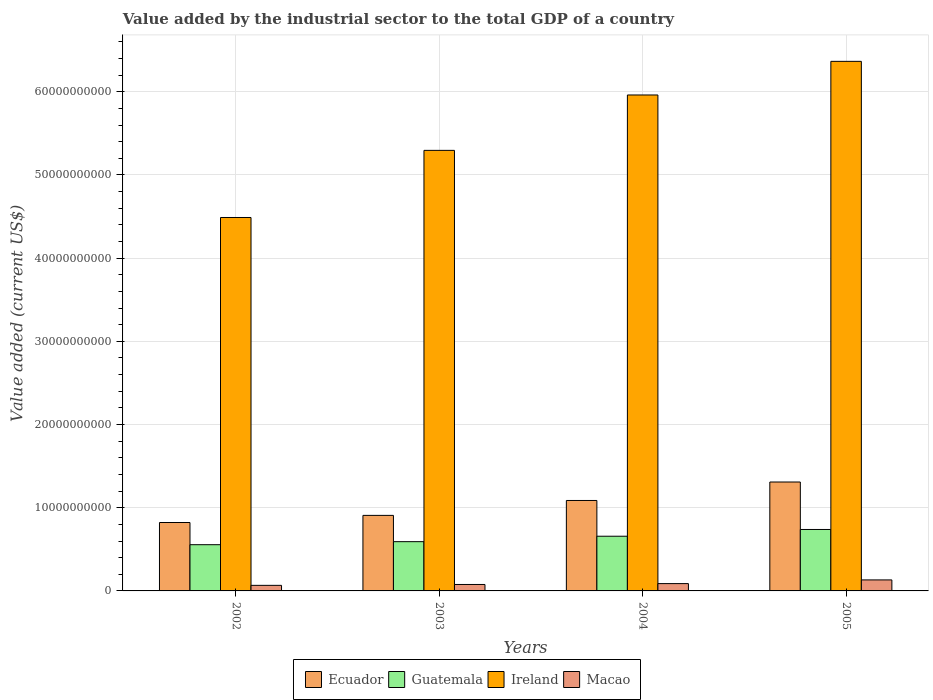Are the number of bars on each tick of the X-axis equal?
Ensure brevity in your answer.  Yes. How many bars are there on the 3rd tick from the left?
Make the answer very short. 4. In how many cases, is the number of bars for a given year not equal to the number of legend labels?
Give a very brief answer. 0. What is the value added by the industrial sector to the total GDP in Ecuador in 2004?
Provide a short and direct response. 1.09e+1. Across all years, what is the maximum value added by the industrial sector to the total GDP in Guatemala?
Your response must be concise. 7.39e+09. Across all years, what is the minimum value added by the industrial sector to the total GDP in Macao?
Provide a short and direct response. 6.69e+08. In which year was the value added by the industrial sector to the total GDP in Guatemala minimum?
Provide a short and direct response. 2002. What is the total value added by the industrial sector to the total GDP in Macao in the graph?
Provide a succinct answer. 3.65e+09. What is the difference between the value added by the industrial sector to the total GDP in Macao in 2004 and that in 2005?
Your answer should be compact. -4.43e+08. What is the difference between the value added by the industrial sector to the total GDP in Ireland in 2003 and the value added by the industrial sector to the total GDP in Guatemala in 2004?
Your answer should be very brief. 4.64e+1. What is the average value added by the industrial sector to the total GDP in Macao per year?
Offer a very short reply. 9.12e+08. In the year 2004, what is the difference between the value added by the industrial sector to the total GDP in Ecuador and value added by the industrial sector to the total GDP in Macao?
Offer a very short reply. 9.99e+09. In how many years, is the value added by the industrial sector to the total GDP in Macao greater than 50000000000 US$?
Provide a succinct answer. 0. What is the ratio of the value added by the industrial sector to the total GDP in Ireland in 2004 to that in 2005?
Ensure brevity in your answer.  0.94. Is the value added by the industrial sector to the total GDP in Macao in 2003 less than that in 2004?
Your answer should be very brief. Yes. What is the difference between the highest and the second highest value added by the industrial sector to the total GDP in Ecuador?
Your response must be concise. 2.22e+09. What is the difference between the highest and the lowest value added by the industrial sector to the total GDP in Macao?
Provide a succinct answer. 6.54e+08. What does the 4th bar from the left in 2005 represents?
Ensure brevity in your answer.  Macao. What does the 4th bar from the right in 2002 represents?
Your response must be concise. Ecuador. Is it the case that in every year, the sum of the value added by the industrial sector to the total GDP in Macao and value added by the industrial sector to the total GDP in Ireland is greater than the value added by the industrial sector to the total GDP in Ecuador?
Ensure brevity in your answer.  Yes. Are the values on the major ticks of Y-axis written in scientific E-notation?
Offer a terse response. No. Does the graph contain grids?
Ensure brevity in your answer.  Yes. Where does the legend appear in the graph?
Make the answer very short. Bottom center. What is the title of the graph?
Provide a short and direct response. Value added by the industrial sector to the total GDP of a country. Does "West Bank and Gaza" appear as one of the legend labels in the graph?
Provide a succinct answer. No. What is the label or title of the Y-axis?
Provide a succinct answer. Value added (current US$). What is the Value added (current US$) in Ecuador in 2002?
Your response must be concise. 8.22e+09. What is the Value added (current US$) in Guatemala in 2002?
Your answer should be compact. 5.56e+09. What is the Value added (current US$) of Ireland in 2002?
Your answer should be compact. 4.49e+1. What is the Value added (current US$) in Macao in 2002?
Make the answer very short. 6.69e+08. What is the Value added (current US$) of Ecuador in 2003?
Your answer should be very brief. 9.08e+09. What is the Value added (current US$) of Guatemala in 2003?
Ensure brevity in your answer.  5.92e+09. What is the Value added (current US$) in Ireland in 2003?
Ensure brevity in your answer.  5.30e+1. What is the Value added (current US$) of Macao in 2003?
Your answer should be compact. 7.75e+08. What is the Value added (current US$) in Ecuador in 2004?
Give a very brief answer. 1.09e+1. What is the Value added (current US$) in Guatemala in 2004?
Ensure brevity in your answer.  6.57e+09. What is the Value added (current US$) in Ireland in 2004?
Keep it short and to the point. 5.96e+1. What is the Value added (current US$) of Macao in 2004?
Your answer should be very brief. 8.80e+08. What is the Value added (current US$) in Ecuador in 2005?
Give a very brief answer. 1.31e+1. What is the Value added (current US$) of Guatemala in 2005?
Provide a succinct answer. 7.39e+09. What is the Value added (current US$) of Ireland in 2005?
Your answer should be very brief. 6.37e+1. What is the Value added (current US$) of Macao in 2005?
Your response must be concise. 1.32e+09. Across all years, what is the maximum Value added (current US$) in Ecuador?
Your answer should be very brief. 1.31e+1. Across all years, what is the maximum Value added (current US$) of Guatemala?
Your answer should be very brief. 7.39e+09. Across all years, what is the maximum Value added (current US$) in Ireland?
Provide a succinct answer. 6.37e+1. Across all years, what is the maximum Value added (current US$) of Macao?
Provide a short and direct response. 1.32e+09. Across all years, what is the minimum Value added (current US$) of Ecuador?
Give a very brief answer. 8.22e+09. Across all years, what is the minimum Value added (current US$) in Guatemala?
Your response must be concise. 5.56e+09. Across all years, what is the minimum Value added (current US$) of Ireland?
Give a very brief answer. 4.49e+1. Across all years, what is the minimum Value added (current US$) of Macao?
Your answer should be very brief. 6.69e+08. What is the total Value added (current US$) in Ecuador in the graph?
Offer a terse response. 4.13e+1. What is the total Value added (current US$) in Guatemala in the graph?
Provide a short and direct response. 2.54e+1. What is the total Value added (current US$) of Ireland in the graph?
Ensure brevity in your answer.  2.21e+11. What is the total Value added (current US$) of Macao in the graph?
Your answer should be compact. 3.65e+09. What is the difference between the Value added (current US$) of Ecuador in 2002 and that in 2003?
Provide a succinct answer. -8.57e+08. What is the difference between the Value added (current US$) of Guatemala in 2002 and that in 2003?
Offer a terse response. -3.64e+08. What is the difference between the Value added (current US$) of Ireland in 2002 and that in 2003?
Give a very brief answer. -8.07e+09. What is the difference between the Value added (current US$) in Macao in 2002 and that in 2003?
Your answer should be very brief. -1.06e+08. What is the difference between the Value added (current US$) of Ecuador in 2002 and that in 2004?
Your answer should be compact. -2.65e+09. What is the difference between the Value added (current US$) of Guatemala in 2002 and that in 2004?
Ensure brevity in your answer.  -1.02e+09. What is the difference between the Value added (current US$) of Ireland in 2002 and that in 2004?
Provide a succinct answer. -1.47e+1. What is the difference between the Value added (current US$) of Macao in 2002 and that in 2004?
Your answer should be compact. -2.12e+08. What is the difference between the Value added (current US$) of Ecuador in 2002 and that in 2005?
Provide a succinct answer. -4.87e+09. What is the difference between the Value added (current US$) of Guatemala in 2002 and that in 2005?
Give a very brief answer. -1.83e+09. What is the difference between the Value added (current US$) of Ireland in 2002 and that in 2005?
Offer a terse response. -1.88e+1. What is the difference between the Value added (current US$) of Macao in 2002 and that in 2005?
Offer a very short reply. -6.54e+08. What is the difference between the Value added (current US$) in Ecuador in 2003 and that in 2004?
Give a very brief answer. -1.79e+09. What is the difference between the Value added (current US$) in Guatemala in 2003 and that in 2004?
Ensure brevity in your answer.  -6.53e+08. What is the difference between the Value added (current US$) of Ireland in 2003 and that in 2004?
Your answer should be compact. -6.66e+09. What is the difference between the Value added (current US$) of Macao in 2003 and that in 2004?
Your response must be concise. -1.05e+08. What is the difference between the Value added (current US$) of Ecuador in 2003 and that in 2005?
Offer a terse response. -4.01e+09. What is the difference between the Value added (current US$) of Guatemala in 2003 and that in 2005?
Offer a very short reply. -1.47e+09. What is the difference between the Value added (current US$) in Ireland in 2003 and that in 2005?
Keep it short and to the point. -1.07e+1. What is the difference between the Value added (current US$) in Macao in 2003 and that in 2005?
Ensure brevity in your answer.  -5.48e+08. What is the difference between the Value added (current US$) in Ecuador in 2004 and that in 2005?
Keep it short and to the point. -2.22e+09. What is the difference between the Value added (current US$) of Guatemala in 2004 and that in 2005?
Provide a short and direct response. -8.13e+08. What is the difference between the Value added (current US$) of Ireland in 2004 and that in 2005?
Give a very brief answer. -4.04e+09. What is the difference between the Value added (current US$) in Macao in 2004 and that in 2005?
Provide a short and direct response. -4.43e+08. What is the difference between the Value added (current US$) in Ecuador in 2002 and the Value added (current US$) in Guatemala in 2003?
Give a very brief answer. 2.30e+09. What is the difference between the Value added (current US$) of Ecuador in 2002 and the Value added (current US$) of Ireland in 2003?
Your answer should be compact. -4.47e+1. What is the difference between the Value added (current US$) in Ecuador in 2002 and the Value added (current US$) in Macao in 2003?
Provide a short and direct response. 7.45e+09. What is the difference between the Value added (current US$) in Guatemala in 2002 and the Value added (current US$) in Ireland in 2003?
Provide a succinct answer. -4.74e+1. What is the difference between the Value added (current US$) in Guatemala in 2002 and the Value added (current US$) in Macao in 2003?
Your answer should be very brief. 4.78e+09. What is the difference between the Value added (current US$) in Ireland in 2002 and the Value added (current US$) in Macao in 2003?
Offer a very short reply. 4.41e+1. What is the difference between the Value added (current US$) in Ecuador in 2002 and the Value added (current US$) in Guatemala in 2004?
Your answer should be very brief. 1.65e+09. What is the difference between the Value added (current US$) of Ecuador in 2002 and the Value added (current US$) of Ireland in 2004?
Make the answer very short. -5.14e+1. What is the difference between the Value added (current US$) in Ecuador in 2002 and the Value added (current US$) in Macao in 2004?
Offer a very short reply. 7.34e+09. What is the difference between the Value added (current US$) in Guatemala in 2002 and the Value added (current US$) in Ireland in 2004?
Offer a very short reply. -5.41e+1. What is the difference between the Value added (current US$) in Guatemala in 2002 and the Value added (current US$) in Macao in 2004?
Ensure brevity in your answer.  4.68e+09. What is the difference between the Value added (current US$) in Ireland in 2002 and the Value added (current US$) in Macao in 2004?
Give a very brief answer. 4.40e+1. What is the difference between the Value added (current US$) of Ecuador in 2002 and the Value added (current US$) of Guatemala in 2005?
Your answer should be compact. 8.37e+08. What is the difference between the Value added (current US$) of Ecuador in 2002 and the Value added (current US$) of Ireland in 2005?
Keep it short and to the point. -5.54e+1. What is the difference between the Value added (current US$) in Ecuador in 2002 and the Value added (current US$) in Macao in 2005?
Offer a very short reply. 6.90e+09. What is the difference between the Value added (current US$) of Guatemala in 2002 and the Value added (current US$) of Ireland in 2005?
Offer a very short reply. -5.81e+1. What is the difference between the Value added (current US$) in Guatemala in 2002 and the Value added (current US$) in Macao in 2005?
Provide a succinct answer. 4.23e+09. What is the difference between the Value added (current US$) of Ireland in 2002 and the Value added (current US$) of Macao in 2005?
Your answer should be very brief. 4.36e+1. What is the difference between the Value added (current US$) of Ecuador in 2003 and the Value added (current US$) of Guatemala in 2004?
Keep it short and to the point. 2.51e+09. What is the difference between the Value added (current US$) of Ecuador in 2003 and the Value added (current US$) of Ireland in 2004?
Ensure brevity in your answer.  -5.05e+1. What is the difference between the Value added (current US$) of Ecuador in 2003 and the Value added (current US$) of Macao in 2004?
Your response must be concise. 8.20e+09. What is the difference between the Value added (current US$) of Guatemala in 2003 and the Value added (current US$) of Ireland in 2004?
Provide a succinct answer. -5.37e+1. What is the difference between the Value added (current US$) of Guatemala in 2003 and the Value added (current US$) of Macao in 2004?
Your answer should be compact. 5.04e+09. What is the difference between the Value added (current US$) of Ireland in 2003 and the Value added (current US$) of Macao in 2004?
Your response must be concise. 5.21e+1. What is the difference between the Value added (current US$) of Ecuador in 2003 and the Value added (current US$) of Guatemala in 2005?
Offer a very short reply. 1.69e+09. What is the difference between the Value added (current US$) in Ecuador in 2003 and the Value added (current US$) in Ireland in 2005?
Ensure brevity in your answer.  -5.46e+1. What is the difference between the Value added (current US$) of Ecuador in 2003 and the Value added (current US$) of Macao in 2005?
Your answer should be very brief. 7.76e+09. What is the difference between the Value added (current US$) of Guatemala in 2003 and the Value added (current US$) of Ireland in 2005?
Keep it short and to the point. -5.77e+1. What is the difference between the Value added (current US$) of Guatemala in 2003 and the Value added (current US$) of Macao in 2005?
Keep it short and to the point. 4.60e+09. What is the difference between the Value added (current US$) of Ireland in 2003 and the Value added (current US$) of Macao in 2005?
Your answer should be compact. 5.16e+1. What is the difference between the Value added (current US$) of Ecuador in 2004 and the Value added (current US$) of Guatemala in 2005?
Give a very brief answer. 3.48e+09. What is the difference between the Value added (current US$) in Ecuador in 2004 and the Value added (current US$) in Ireland in 2005?
Give a very brief answer. -5.28e+1. What is the difference between the Value added (current US$) in Ecuador in 2004 and the Value added (current US$) in Macao in 2005?
Ensure brevity in your answer.  9.55e+09. What is the difference between the Value added (current US$) in Guatemala in 2004 and the Value added (current US$) in Ireland in 2005?
Ensure brevity in your answer.  -5.71e+1. What is the difference between the Value added (current US$) of Guatemala in 2004 and the Value added (current US$) of Macao in 2005?
Your answer should be compact. 5.25e+09. What is the difference between the Value added (current US$) of Ireland in 2004 and the Value added (current US$) of Macao in 2005?
Make the answer very short. 5.83e+1. What is the average Value added (current US$) of Ecuador per year?
Keep it short and to the point. 1.03e+1. What is the average Value added (current US$) in Guatemala per year?
Offer a very short reply. 6.36e+09. What is the average Value added (current US$) of Ireland per year?
Offer a terse response. 5.53e+1. What is the average Value added (current US$) of Macao per year?
Your answer should be very brief. 9.12e+08. In the year 2002, what is the difference between the Value added (current US$) of Ecuador and Value added (current US$) of Guatemala?
Ensure brevity in your answer.  2.67e+09. In the year 2002, what is the difference between the Value added (current US$) in Ecuador and Value added (current US$) in Ireland?
Provide a short and direct response. -3.67e+1. In the year 2002, what is the difference between the Value added (current US$) in Ecuador and Value added (current US$) in Macao?
Offer a terse response. 7.56e+09. In the year 2002, what is the difference between the Value added (current US$) of Guatemala and Value added (current US$) of Ireland?
Your answer should be very brief. -3.93e+1. In the year 2002, what is the difference between the Value added (current US$) in Guatemala and Value added (current US$) in Macao?
Offer a terse response. 4.89e+09. In the year 2002, what is the difference between the Value added (current US$) in Ireland and Value added (current US$) in Macao?
Your answer should be very brief. 4.42e+1. In the year 2003, what is the difference between the Value added (current US$) in Ecuador and Value added (current US$) in Guatemala?
Provide a succinct answer. 3.16e+09. In the year 2003, what is the difference between the Value added (current US$) of Ecuador and Value added (current US$) of Ireland?
Your answer should be very brief. -4.39e+1. In the year 2003, what is the difference between the Value added (current US$) of Ecuador and Value added (current US$) of Macao?
Your answer should be compact. 8.31e+09. In the year 2003, what is the difference between the Value added (current US$) in Guatemala and Value added (current US$) in Ireland?
Give a very brief answer. -4.70e+1. In the year 2003, what is the difference between the Value added (current US$) in Guatemala and Value added (current US$) in Macao?
Provide a succinct answer. 5.15e+09. In the year 2003, what is the difference between the Value added (current US$) of Ireland and Value added (current US$) of Macao?
Your response must be concise. 5.22e+1. In the year 2004, what is the difference between the Value added (current US$) of Ecuador and Value added (current US$) of Guatemala?
Your response must be concise. 4.30e+09. In the year 2004, what is the difference between the Value added (current US$) in Ecuador and Value added (current US$) in Ireland?
Keep it short and to the point. -4.87e+1. In the year 2004, what is the difference between the Value added (current US$) in Ecuador and Value added (current US$) in Macao?
Provide a succinct answer. 9.99e+09. In the year 2004, what is the difference between the Value added (current US$) in Guatemala and Value added (current US$) in Ireland?
Your answer should be compact. -5.30e+1. In the year 2004, what is the difference between the Value added (current US$) of Guatemala and Value added (current US$) of Macao?
Make the answer very short. 5.69e+09. In the year 2004, what is the difference between the Value added (current US$) in Ireland and Value added (current US$) in Macao?
Provide a short and direct response. 5.87e+1. In the year 2005, what is the difference between the Value added (current US$) of Ecuador and Value added (current US$) of Guatemala?
Offer a very short reply. 5.71e+09. In the year 2005, what is the difference between the Value added (current US$) of Ecuador and Value added (current US$) of Ireland?
Offer a very short reply. -5.06e+1. In the year 2005, what is the difference between the Value added (current US$) of Ecuador and Value added (current US$) of Macao?
Your response must be concise. 1.18e+1. In the year 2005, what is the difference between the Value added (current US$) of Guatemala and Value added (current US$) of Ireland?
Provide a succinct answer. -5.63e+1. In the year 2005, what is the difference between the Value added (current US$) in Guatemala and Value added (current US$) in Macao?
Make the answer very short. 6.06e+09. In the year 2005, what is the difference between the Value added (current US$) of Ireland and Value added (current US$) of Macao?
Offer a terse response. 6.23e+1. What is the ratio of the Value added (current US$) of Ecuador in 2002 to that in 2003?
Give a very brief answer. 0.91. What is the ratio of the Value added (current US$) in Guatemala in 2002 to that in 2003?
Offer a very short reply. 0.94. What is the ratio of the Value added (current US$) in Ireland in 2002 to that in 2003?
Your answer should be very brief. 0.85. What is the ratio of the Value added (current US$) of Macao in 2002 to that in 2003?
Offer a very short reply. 0.86. What is the ratio of the Value added (current US$) of Ecuador in 2002 to that in 2004?
Ensure brevity in your answer.  0.76. What is the ratio of the Value added (current US$) in Guatemala in 2002 to that in 2004?
Offer a very short reply. 0.85. What is the ratio of the Value added (current US$) of Ireland in 2002 to that in 2004?
Provide a succinct answer. 0.75. What is the ratio of the Value added (current US$) of Macao in 2002 to that in 2004?
Your response must be concise. 0.76. What is the ratio of the Value added (current US$) in Ecuador in 2002 to that in 2005?
Your answer should be very brief. 0.63. What is the ratio of the Value added (current US$) in Guatemala in 2002 to that in 2005?
Ensure brevity in your answer.  0.75. What is the ratio of the Value added (current US$) of Ireland in 2002 to that in 2005?
Ensure brevity in your answer.  0.71. What is the ratio of the Value added (current US$) of Macao in 2002 to that in 2005?
Your response must be concise. 0.51. What is the ratio of the Value added (current US$) in Ecuador in 2003 to that in 2004?
Your response must be concise. 0.84. What is the ratio of the Value added (current US$) of Guatemala in 2003 to that in 2004?
Keep it short and to the point. 0.9. What is the ratio of the Value added (current US$) in Ireland in 2003 to that in 2004?
Give a very brief answer. 0.89. What is the ratio of the Value added (current US$) in Macao in 2003 to that in 2004?
Provide a succinct answer. 0.88. What is the ratio of the Value added (current US$) in Ecuador in 2003 to that in 2005?
Keep it short and to the point. 0.69. What is the ratio of the Value added (current US$) of Guatemala in 2003 to that in 2005?
Provide a short and direct response. 0.8. What is the ratio of the Value added (current US$) of Ireland in 2003 to that in 2005?
Provide a succinct answer. 0.83. What is the ratio of the Value added (current US$) of Macao in 2003 to that in 2005?
Your answer should be compact. 0.59. What is the ratio of the Value added (current US$) of Ecuador in 2004 to that in 2005?
Provide a short and direct response. 0.83. What is the ratio of the Value added (current US$) in Guatemala in 2004 to that in 2005?
Offer a terse response. 0.89. What is the ratio of the Value added (current US$) of Ireland in 2004 to that in 2005?
Provide a short and direct response. 0.94. What is the ratio of the Value added (current US$) in Macao in 2004 to that in 2005?
Offer a terse response. 0.67. What is the difference between the highest and the second highest Value added (current US$) of Ecuador?
Provide a succinct answer. 2.22e+09. What is the difference between the highest and the second highest Value added (current US$) in Guatemala?
Keep it short and to the point. 8.13e+08. What is the difference between the highest and the second highest Value added (current US$) of Ireland?
Ensure brevity in your answer.  4.04e+09. What is the difference between the highest and the second highest Value added (current US$) in Macao?
Give a very brief answer. 4.43e+08. What is the difference between the highest and the lowest Value added (current US$) of Ecuador?
Your response must be concise. 4.87e+09. What is the difference between the highest and the lowest Value added (current US$) of Guatemala?
Offer a terse response. 1.83e+09. What is the difference between the highest and the lowest Value added (current US$) in Ireland?
Provide a short and direct response. 1.88e+1. What is the difference between the highest and the lowest Value added (current US$) in Macao?
Provide a succinct answer. 6.54e+08. 